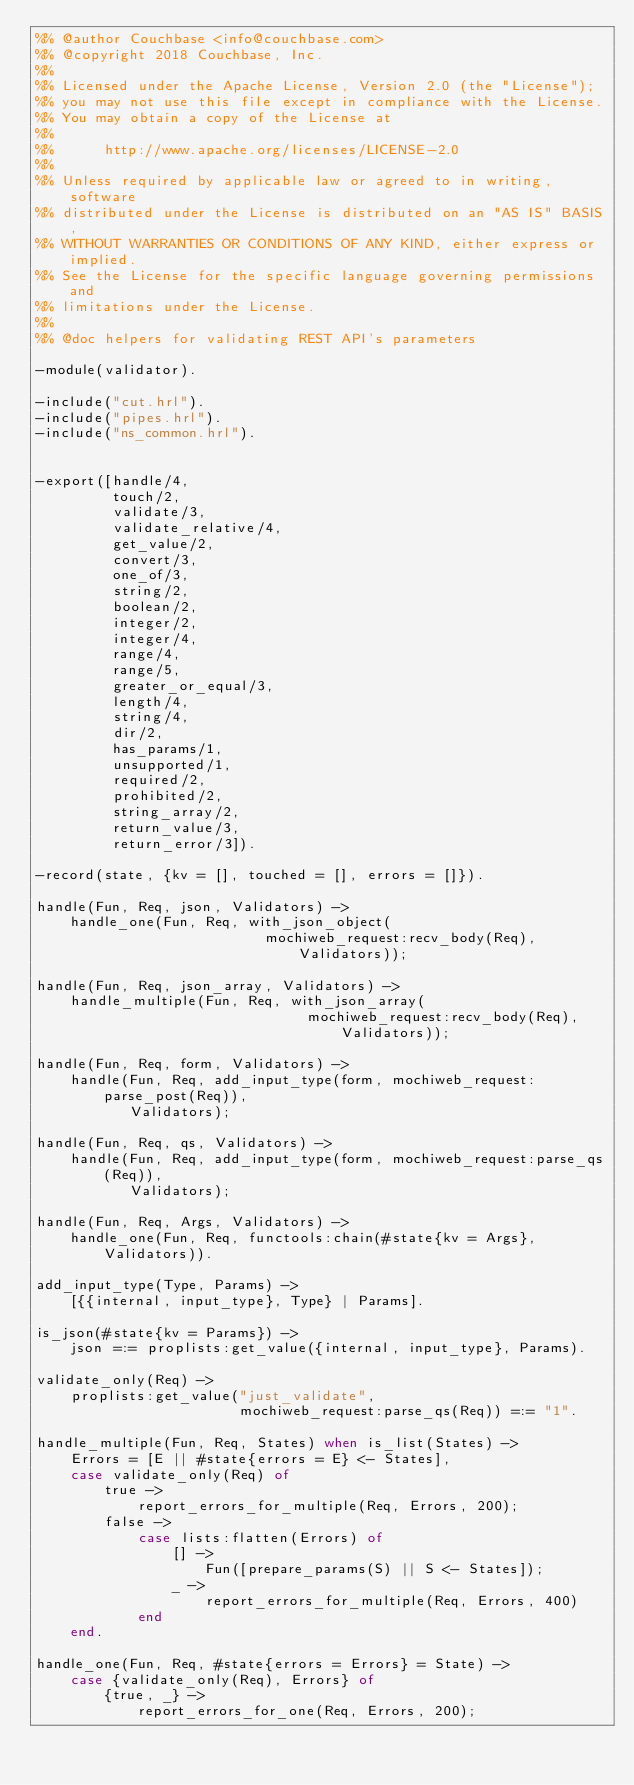<code> <loc_0><loc_0><loc_500><loc_500><_Erlang_>%% @author Couchbase <info@couchbase.com>
%% @copyright 2018 Couchbase, Inc.
%%
%% Licensed under the Apache License, Version 2.0 (the "License");
%% you may not use this file except in compliance with the License.
%% You may obtain a copy of the License at
%%
%%      http://www.apache.org/licenses/LICENSE-2.0
%%
%% Unless required by applicable law or agreed to in writing, software
%% distributed under the License is distributed on an "AS IS" BASIS,
%% WITHOUT WARRANTIES OR CONDITIONS OF ANY KIND, either express or implied.
%% See the License for the specific language governing permissions and
%% limitations under the License.
%%
%% @doc helpers for validating REST API's parameters

-module(validator).

-include("cut.hrl").
-include("pipes.hrl").
-include("ns_common.hrl").


-export([handle/4,
         touch/2,
         validate/3,
         validate_relative/4,
         get_value/2,
         convert/3,
         one_of/3,
         string/2,
         boolean/2,
         integer/2,
         integer/4,
         range/4,
         range/5,
         greater_or_equal/3,
         length/4,
         string/4,
         dir/2,
         has_params/1,
         unsupported/1,
         required/2,
         prohibited/2,
         string_array/2,
         return_value/3,
         return_error/3]).

-record(state, {kv = [], touched = [], errors = []}).

handle(Fun, Req, json, Validators) ->
    handle_one(Fun, Req, with_json_object(
                           mochiweb_request:recv_body(Req), Validators));

handle(Fun, Req, json_array, Validators) ->
    handle_multiple(Fun, Req, with_json_array(
                                mochiweb_request:recv_body(Req), Validators));

handle(Fun, Req, form, Validators) ->
    handle(Fun, Req, add_input_type(form, mochiweb_request:parse_post(Req)),
           Validators);

handle(Fun, Req, qs, Validators) ->
    handle(Fun, Req, add_input_type(form, mochiweb_request:parse_qs(Req)),
           Validators);

handle(Fun, Req, Args, Validators) ->
    handle_one(Fun, Req, functools:chain(#state{kv = Args}, Validators)).

add_input_type(Type, Params) ->
    [{{internal, input_type}, Type} | Params].

is_json(#state{kv = Params}) ->
    json =:= proplists:get_value({internal, input_type}, Params).

validate_only(Req) ->
    proplists:get_value("just_validate",
                        mochiweb_request:parse_qs(Req)) =:= "1".

handle_multiple(Fun, Req, States) when is_list(States) ->
    Errors = [E || #state{errors = E} <- States],
    case validate_only(Req) of
        true ->
            report_errors_for_multiple(Req, Errors, 200);
        false ->
            case lists:flatten(Errors) of
                [] ->
                    Fun([prepare_params(S) || S <- States]);
                _ ->
                    report_errors_for_multiple(Req, Errors, 400)
            end
    end.

handle_one(Fun, Req, #state{errors = Errors} = State) ->
    case {validate_only(Req), Errors} of
        {true, _} ->
            report_errors_for_one(Req, Errors, 200);</code> 